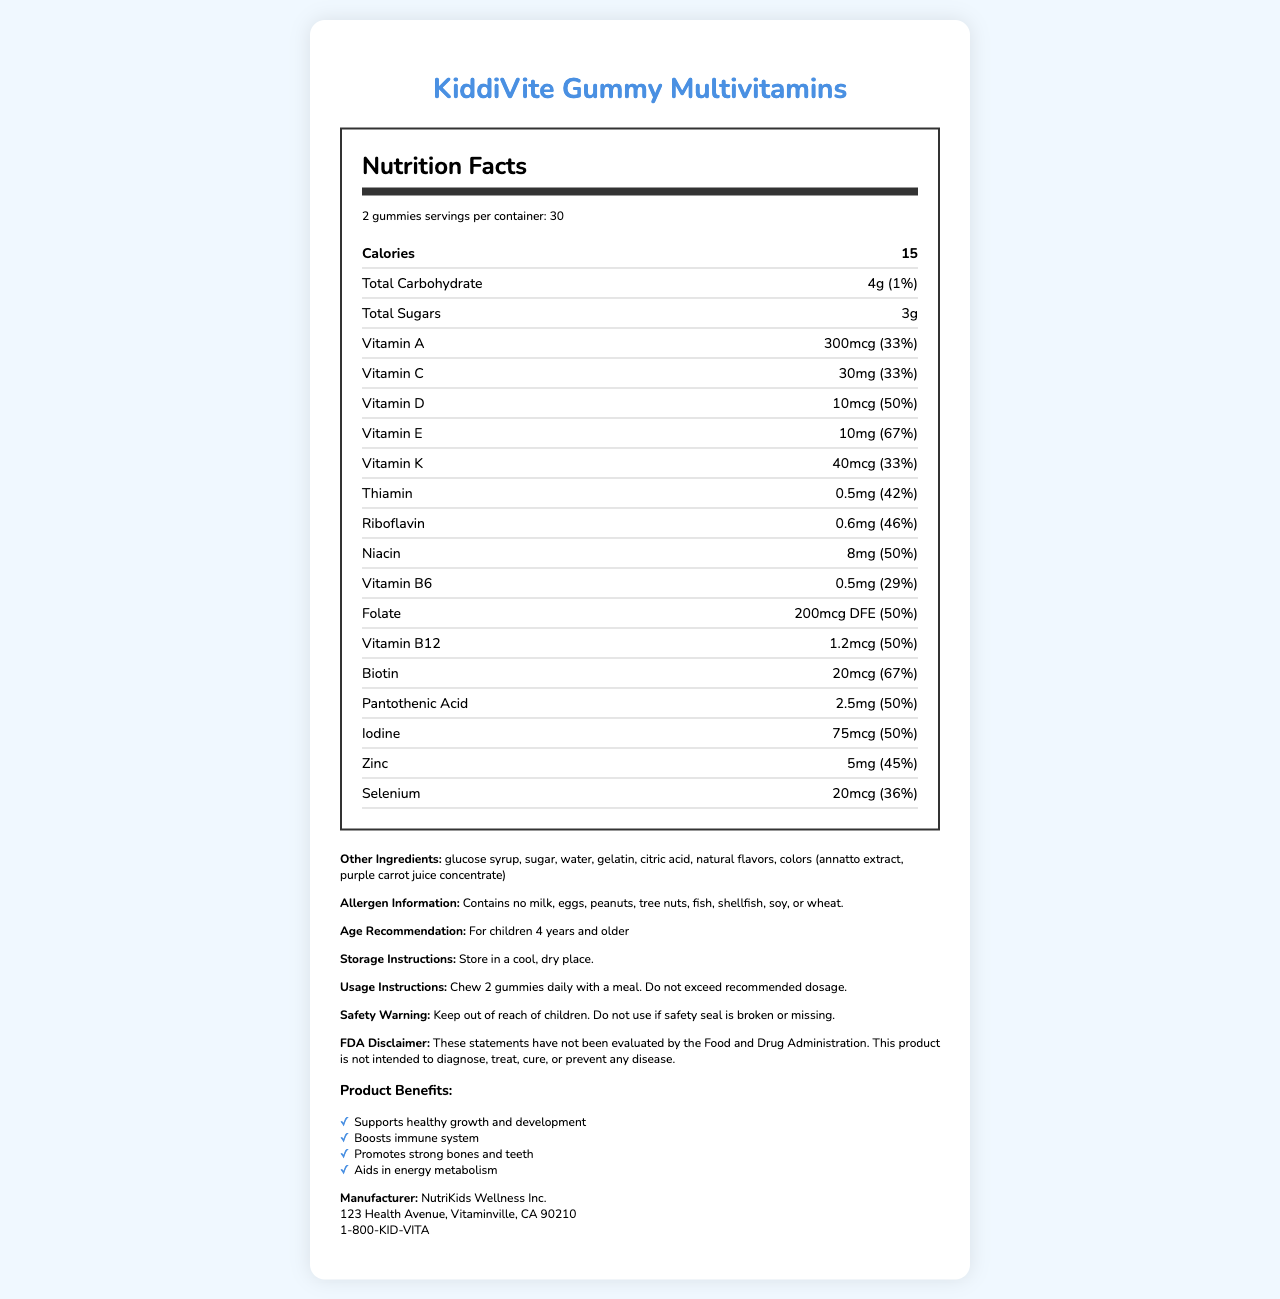what is the serving size? The serving size is listed at the top of the nutrition facts section as "2 gummies".
Answer: 2 gummies How many calories are in one serving? The document states that there are 15 calories per serving.
Answer: 15 calories What is the amount of total carbohydrates in one serving? The label indicates that the amount of total carbohydrates per serving is 4 grams.
Answer: 4g what is the percentage of daily value for Vitamin A? According to the document, one serving provides 33% of the daily value for Vitamin A.
Answer: 33% What does the allergen information section specify? The allergen section clearly states that the product contains none of these allergens.
Answer: Contains no milk, eggs, peanuts, tree nuts, fish, shellfish, soy, or wheat. What are the instructions for storage? The storage instructions mentioned in the document are to store the product in a cool, dry place.
Answer: Store in a cool, dry place. Which nutrient has the highest daily value percentage per serving? The document shows that Vitamin E has the highest daily value percentage per serving at 67%.
Answer: Vitamin E (67%) What are the usage instructions for this product? The usage instructions state to chew 2 gummies daily with a meal and not to exceed the recommended dosage.
Answer: Chew 2 gummies daily with a meal. Do not exceed recommended dosage. For which age group is this product recommended? The document specifies that the product is recommended for children aged 4 years and older.
Answer: For children 4 years and older is this statement true or false: This product is intended to diagnose, treat, cure, or prevent disease. The FDA disclaimer explicitly states that this product is not intended to diagnose, treat, cure, or prevent any disease.
Answer: False Which of the following is true regarding the iodine content per serving?
    A. 25 mcg
    B. 50 mcg
    C. 75 mcg
    D. 100 mcg The document specifies 75 mcg of iodine per serving.
Answer: C Select the correct manufacturer address: 
    I. 123 Health Avenue, Vitaminville, CA 90210
    II. 456 Wellness Street, Healthtown, TX 75001
    III. 789 Nutrition Road, Suplementcity, FL 33101 The manufacturer address given in the document is 123 Health Avenue, Vitaminville, CA 90210.
Answer: I Describe the entire document or the main idea. The document provides comprehensive nutritional information about the product, detailing its contents, how to use and store it, the recommended age group, and the benefits of its consumption, along with manufacturer and safety details.
Answer: The document is the Nutrition Facts Label for KiddiVite Gummy Multivitamins, providing detailed information about serving size, calorie count, and the percentage of daily values for various vitamins and minerals. It includes additional information such as other ingredients, allergen information, age recommendations, storage instructions, usage instructions, safety warnings, FDA disclaimer, product benefits, and manufacturer details. How much selenium is contained in one serving? The label specifies that one serving contains 20 mcg of selenium.
Answer: 20 mcg Which statement is not present in the document?
    A. Contains no artificial preservatives
    B. Chew 2 gummies daily with a meal
    C. These statements have not been evaluated by the FDA The document does not mention that the product contains no artificial preservatives, while the other two statements are present.
Answer: A What is the contact number for NutriKids Wellness Inc.? The manufacturer information section lists the contact number as 1-800-KID-VITA.
Answer: 1-800-KID-VITA What is the cumulative percentage of daily value for Vitamin D and Vitamin C together per serving? Vitamin D has 50% and Vitamin C has 33% of the daily value per serving, summing up to 83%.
Answer: 83% What is the exact color specification mentioned in the ingredients list? The document lists the specific colors in the ingredients as annatto extract and purple carrot juice concentrate.
Answer: colors (annatto extract, purple carrot juice concentrate) What is the expiration date of the product? The document does not provide information regarding the expiration date of the product.
Answer: Cannot be determined 